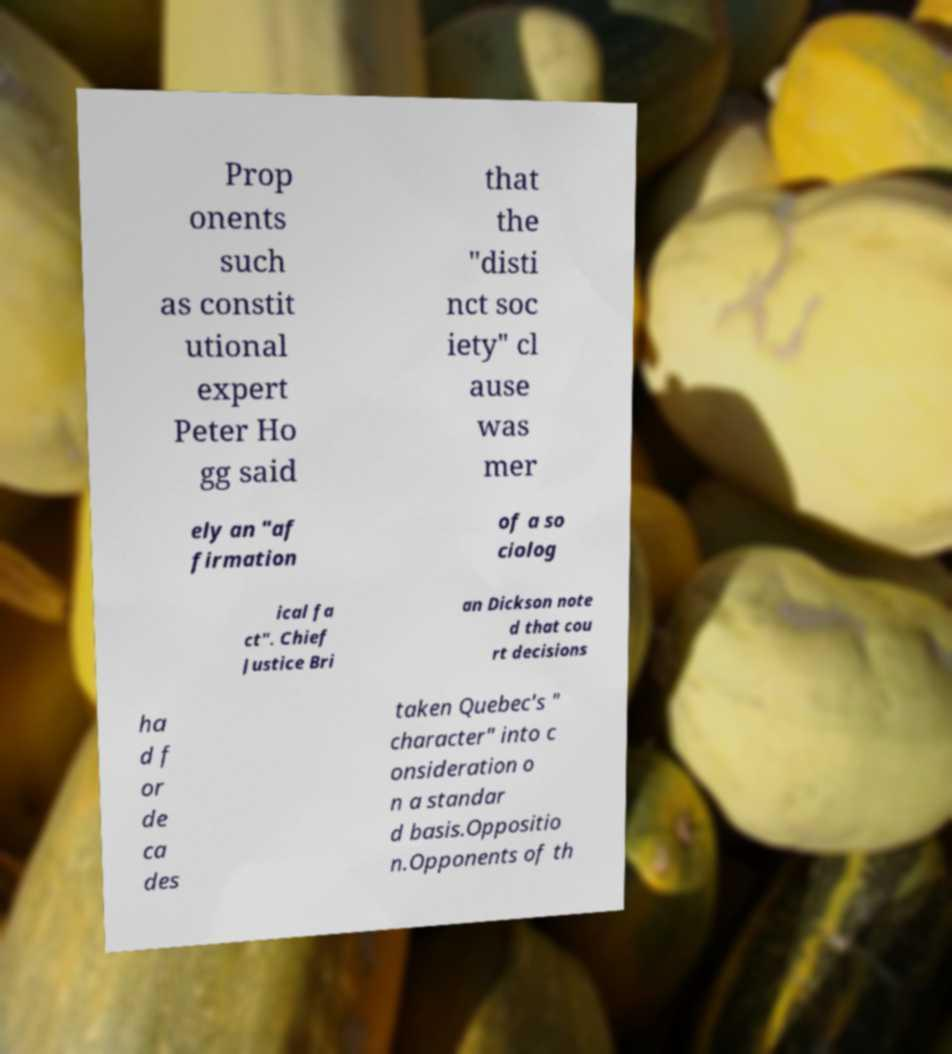Please identify and transcribe the text found in this image. Prop onents such as constit utional expert Peter Ho gg said that the "disti nct soc iety" cl ause was mer ely an "af firmation of a so ciolog ical fa ct". Chief Justice Bri an Dickson note d that cou rt decisions ha d f or de ca des taken Quebec's " character" into c onsideration o n a standar d basis.Oppositio n.Opponents of th 